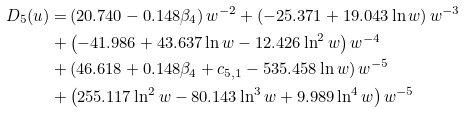Convert formula to latex. <formula><loc_0><loc_0><loc_500><loc_500>D _ { 5 } ( u ) = & \left ( 2 0 . 7 4 0 - 0 . 1 4 8 \beta _ { 4 } \right ) w ^ { - 2 } + \left ( - 2 5 . 3 7 1 + 1 9 . 0 4 3 \ln w \right ) w ^ { - 3 } \\ + & \left ( - 4 1 . 9 8 6 + 4 3 . 6 3 7 \ln w - 1 2 . 4 2 6 \ln ^ { 2 } w \right ) w ^ { - 4 } \\ + & \left ( 4 6 . 6 1 8 + 0 . 1 4 8 \beta _ { 4 } + c _ { 5 , 1 } - 5 3 5 . 4 5 8 \ln w \right ) w ^ { - 5 } \\ + & \left ( 2 5 5 . 1 1 7 \ln ^ { 2 } w - 8 0 . 1 4 3 \ln ^ { 3 } w + 9 . 9 8 9 \ln ^ { 4 } w \right ) w ^ { - 5 }</formula> 